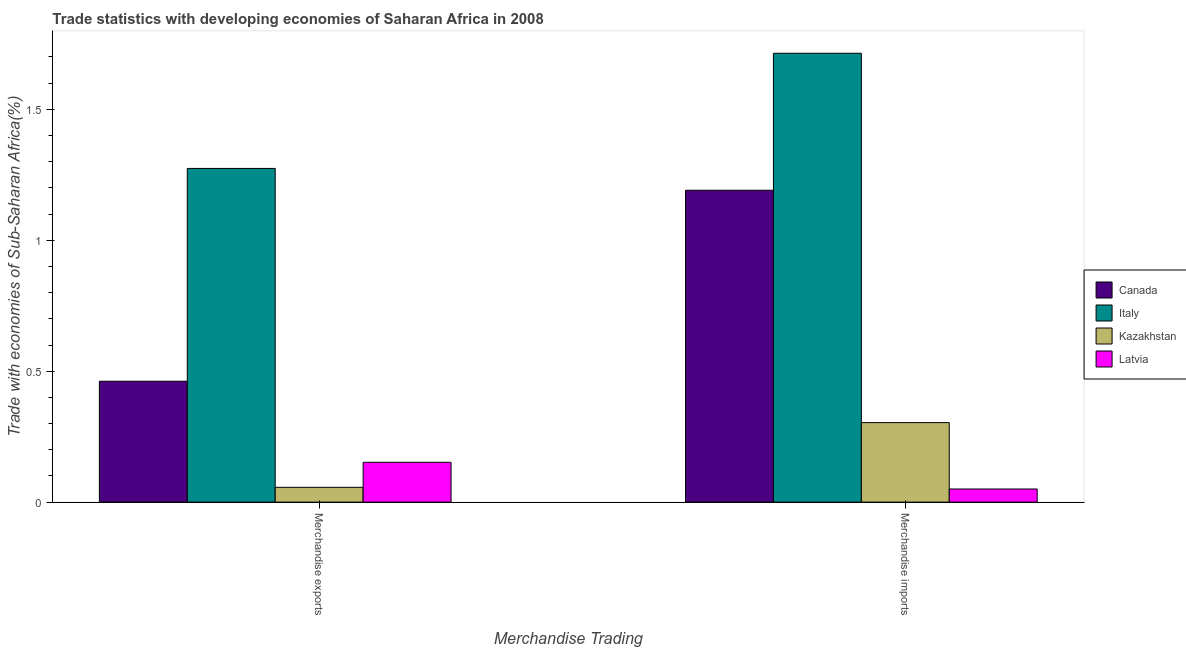How many groups of bars are there?
Your answer should be compact. 2. How many bars are there on the 1st tick from the left?
Provide a succinct answer. 4. How many bars are there on the 1st tick from the right?
Give a very brief answer. 4. What is the merchandise exports in Canada?
Ensure brevity in your answer.  0.46. Across all countries, what is the maximum merchandise exports?
Give a very brief answer. 1.27. Across all countries, what is the minimum merchandise exports?
Make the answer very short. 0.06. In which country was the merchandise exports minimum?
Keep it short and to the point. Kazakhstan. What is the total merchandise exports in the graph?
Ensure brevity in your answer.  1.94. What is the difference between the merchandise exports in Kazakhstan and that in Latvia?
Make the answer very short. -0.1. What is the difference between the merchandise imports in Latvia and the merchandise exports in Canada?
Provide a succinct answer. -0.41. What is the average merchandise exports per country?
Your answer should be compact. 0.49. What is the difference between the merchandise imports and merchandise exports in Latvia?
Give a very brief answer. -0.1. In how many countries, is the merchandise imports greater than 1 %?
Provide a succinct answer. 2. What is the ratio of the merchandise imports in Canada to that in Italy?
Your answer should be compact. 0.69. What does the 2nd bar from the left in Merchandise imports represents?
Make the answer very short. Italy. What does the 2nd bar from the right in Merchandise imports represents?
Keep it short and to the point. Kazakhstan. Are all the bars in the graph horizontal?
Provide a short and direct response. No. Does the graph contain grids?
Provide a succinct answer. No. How many legend labels are there?
Offer a very short reply. 4. How are the legend labels stacked?
Give a very brief answer. Vertical. What is the title of the graph?
Provide a short and direct response. Trade statistics with developing economies of Saharan Africa in 2008. Does "Armenia" appear as one of the legend labels in the graph?
Offer a very short reply. No. What is the label or title of the X-axis?
Provide a succinct answer. Merchandise Trading. What is the label or title of the Y-axis?
Your answer should be very brief. Trade with economies of Sub-Saharan Africa(%). What is the Trade with economies of Sub-Saharan Africa(%) of Canada in Merchandise exports?
Make the answer very short. 0.46. What is the Trade with economies of Sub-Saharan Africa(%) of Italy in Merchandise exports?
Ensure brevity in your answer.  1.27. What is the Trade with economies of Sub-Saharan Africa(%) in Kazakhstan in Merchandise exports?
Your answer should be compact. 0.06. What is the Trade with economies of Sub-Saharan Africa(%) in Latvia in Merchandise exports?
Offer a terse response. 0.15. What is the Trade with economies of Sub-Saharan Africa(%) in Canada in Merchandise imports?
Ensure brevity in your answer.  1.19. What is the Trade with economies of Sub-Saharan Africa(%) of Italy in Merchandise imports?
Your answer should be compact. 1.71. What is the Trade with economies of Sub-Saharan Africa(%) of Kazakhstan in Merchandise imports?
Your answer should be compact. 0.3. What is the Trade with economies of Sub-Saharan Africa(%) of Latvia in Merchandise imports?
Provide a succinct answer. 0.05. Across all Merchandise Trading, what is the maximum Trade with economies of Sub-Saharan Africa(%) of Canada?
Your response must be concise. 1.19. Across all Merchandise Trading, what is the maximum Trade with economies of Sub-Saharan Africa(%) of Italy?
Your response must be concise. 1.71. Across all Merchandise Trading, what is the maximum Trade with economies of Sub-Saharan Africa(%) in Kazakhstan?
Make the answer very short. 0.3. Across all Merchandise Trading, what is the maximum Trade with economies of Sub-Saharan Africa(%) of Latvia?
Your answer should be compact. 0.15. Across all Merchandise Trading, what is the minimum Trade with economies of Sub-Saharan Africa(%) in Canada?
Your answer should be very brief. 0.46. Across all Merchandise Trading, what is the minimum Trade with economies of Sub-Saharan Africa(%) of Italy?
Keep it short and to the point. 1.27. Across all Merchandise Trading, what is the minimum Trade with economies of Sub-Saharan Africa(%) of Kazakhstan?
Make the answer very short. 0.06. Across all Merchandise Trading, what is the minimum Trade with economies of Sub-Saharan Africa(%) of Latvia?
Provide a succinct answer. 0.05. What is the total Trade with economies of Sub-Saharan Africa(%) in Canada in the graph?
Offer a terse response. 1.65. What is the total Trade with economies of Sub-Saharan Africa(%) of Italy in the graph?
Offer a very short reply. 2.99. What is the total Trade with economies of Sub-Saharan Africa(%) in Kazakhstan in the graph?
Your response must be concise. 0.36. What is the total Trade with economies of Sub-Saharan Africa(%) in Latvia in the graph?
Provide a succinct answer. 0.2. What is the difference between the Trade with economies of Sub-Saharan Africa(%) of Canada in Merchandise exports and that in Merchandise imports?
Keep it short and to the point. -0.73. What is the difference between the Trade with economies of Sub-Saharan Africa(%) of Italy in Merchandise exports and that in Merchandise imports?
Your response must be concise. -0.44. What is the difference between the Trade with economies of Sub-Saharan Africa(%) of Kazakhstan in Merchandise exports and that in Merchandise imports?
Ensure brevity in your answer.  -0.25. What is the difference between the Trade with economies of Sub-Saharan Africa(%) of Latvia in Merchandise exports and that in Merchandise imports?
Ensure brevity in your answer.  0.1. What is the difference between the Trade with economies of Sub-Saharan Africa(%) in Canada in Merchandise exports and the Trade with economies of Sub-Saharan Africa(%) in Italy in Merchandise imports?
Provide a short and direct response. -1.25. What is the difference between the Trade with economies of Sub-Saharan Africa(%) of Canada in Merchandise exports and the Trade with economies of Sub-Saharan Africa(%) of Kazakhstan in Merchandise imports?
Ensure brevity in your answer.  0.16. What is the difference between the Trade with economies of Sub-Saharan Africa(%) in Canada in Merchandise exports and the Trade with economies of Sub-Saharan Africa(%) in Latvia in Merchandise imports?
Offer a very short reply. 0.41. What is the difference between the Trade with economies of Sub-Saharan Africa(%) of Italy in Merchandise exports and the Trade with economies of Sub-Saharan Africa(%) of Kazakhstan in Merchandise imports?
Keep it short and to the point. 0.97. What is the difference between the Trade with economies of Sub-Saharan Africa(%) of Italy in Merchandise exports and the Trade with economies of Sub-Saharan Africa(%) of Latvia in Merchandise imports?
Give a very brief answer. 1.22. What is the difference between the Trade with economies of Sub-Saharan Africa(%) in Kazakhstan in Merchandise exports and the Trade with economies of Sub-Saharan Africa(%) in Latvia in Merchandise imports?
Give a very brief answer. 0.01. What is the average Trade with economies of Sub-Saharan Africa(%) of Canada per Merchandise Trading?
Keep it short and to the point. 0.83. What is the average Trade with economies of Sub-Saharan Africa(%) in Italy per Merchandise Trading?
Keep it short and to the point. 1.49. What is the average Trade with economies of Sub-Saharan Africa(%) in Kazakhstan per Merchandise Trading?
Make the answer very short. 0.18. What is the average Trade with economies of Sub-Saharan Africa(%) in Latvia per Merchandise Trading?
Provide a succinct answer. 0.1. What is the difference between the Trade with economies of Sub-Saharan Africa(%) of Canada and Trade with economies of Sub-Saharan Africa(%) of Italy in Merchandise exports?
Offer a terse response. -0.81. What is the difference between the Trade with economies of Sub-Saharan Africa(%) in Canada and Trade with economies of Sub-Saharan Africa(%) in Kazakhstan in Merchandise exports?
Offer a very short reply. 0.41. What is the difference between the Trade with economies of Sub-Saharan Africa(%) in Canada and Trade with economies of Sub-Saharan Africa(%) in Latvia in Merchandise exports?
Give a very brief answer. 0.31. What is the difference between the Trade with economies of Sub-Saharan Africa(%) of Italy and Trade with economies of Sub-Saharan Africa(%) of Kazakhstan in Merchandise exports?
Your answer should be compact. 1.22. What is the difference between the Trade with economies of Sub-Saharan Africa(%) of Italy and Trade with economies of Sub-Saharan Africa(%) of Latvia in Merchandise exports?
Your answer should be very brief. 1.12. What is the difference between the Trade with economies of Sub-Saharan Africa(%) of Kazakhstan and Trade with economies of Sub-Saharan Africa(%) of Latvia in Merchandise exports?
Keep it short and to the point. -0.1. What is the difference between the Trade with economies of Sub-Saharan Africa(%) of Canada and Trade with economies of Sub-Saharan Africa(%) of Italy in Merchandise imports?
Keep it short and to the point. -0.52. What is the difference between the Trade with economies of Sub-Saharan Africa(%) of Canada and Trade with economies of Sub-Saharan Africa(%) of Kazakhstan in Merchandise imports?
Provide a short and direct response. 0.89. What is the difference between the Trade with economies of Sub-Saharan Africa(%) in Canada and Trade with economies of Sub-Saharan Africa(%) in Latvia in Merchandise imports?
Make the answer very short. 1.14. What is the difference between the Trade with economies of Sub-Saharan Africa(%) in Italy and Trade with economies of Sub-Saharan Africa(%) in Kazakhstan in Merchandise imports?
Keep it short and to the point. 1.41. What is the difference between the Trade with economies of Sub-Saharan Africa(%) of Italy and Trade with economies of Sub-Saharan Africa(%) of Latvia in Merchandise imports?
Give a very brief answer. 1.66. What is the difference between the Trade with economies of Sub-Saharan Africa(%) in Kazakhstan and Trade with economies of Sub-Saharan Africa(%) in Latvia in Merchandise imports?
Your answer should be compact. 0.25. What is the ratio of the Trade with economies of Sub-Saharan Africa(%) in Canada in Merchandise exports to that in Merchandise imports?
Offer a very short reply. 0.39. What is the ratio of the Trade with economies of Sub-Saharan Africa(%) in Italy in Merchandise exports to that in Merchandise imports?
Offer a very short reply. 0.74. What is the ratio of the Trade with economies of Sub-Saharan Africa(%) of Kazakhstan in Merchandise exports to that in Merchandise imports?
Provide a succinct answer. 0.19. What is the ratio of the Trade with economies of Sub-Saharan Africa(%) in Latvia in Merchandise exports to that in Merchandise imports?
Ensure brevity in your answer.  3.03. What is the difference between the highest and the second highest Trade with economies of Sub-Saharan Africa(%) of Canada?
Your answer should be very brief. 0.73. What is the difference between the highest and the second highest Trade with economies of Sub-Saharan Africa(%) in Italy?
Give a very brief answer. 0.44. What is the difference between the highest and the second highest Trade with economies of Sub-Saharan Africa(%) of Kazakhstan?
Your answer should be very brief. 0.25. What is the difference between the highest and the second highest Trade with economies of Sub-Saharan Africa(%) of Latvia?
Offer a terse response. 0.1. What is the difference between the highest and the lowest Trade with economies of Sub-Saharan Africa(%) in Canada?
Give a very brief answer. 0.73. What is the difference between the highest and the lowest Trade with economies of Sub-Saharan Africa(%) in Italy?
Your response must be concise. 0.44. What is the difference between the highest and the lowest Trade with economies of Sub-Saharan Africa(%) in Kazakhstan?
Your response must be concise. 0.25. What is the difference between the highest and the lowest Trade with economies of Sub-Saharan Africa(%) in Latvia?
Make the answer very short. 0.1. 